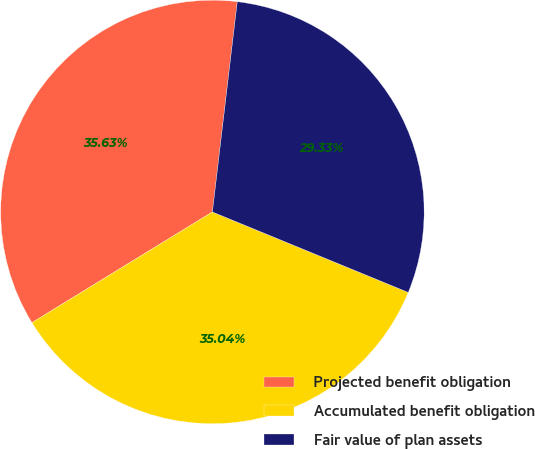<chart> <loc_0><loc_0><loc_500><loc_500><pie_chart><fcel>Projected benefit obligation<fcel>Accumulated benefit obligation<fcel>Fair value of plan assets<nl><fcel>35.63%<fcel>35.04%<fcel>29.33%<nl></chart> 